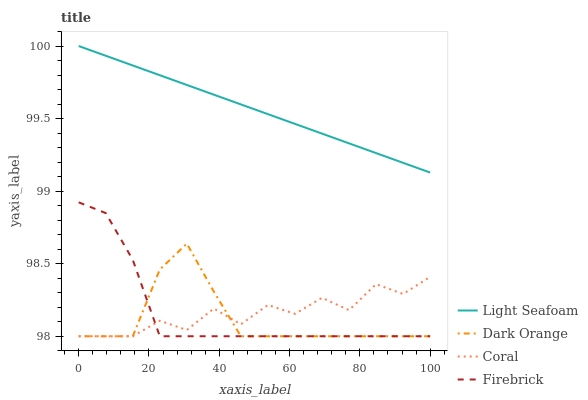Does Dark Orange have the minimum area under the curve?
Answer yes or no. Yes. Does Light Seafoam have the maximum area under the curve?
Answer yes or no. Yes. Does Coral have the minimum area under the curve?
Answer yes or no. No. Does Coral have the maximum area under the curve?
Answer yes or no. No. Is Light Seafoam the smoothest?
Answer yes or no. Yes. Is Coral the roughest?
Answer yes or no. Yes. Is Coral the smoothest?
Answer yes or no. No. Is Light Seafoam the roughest?
Answer yes or no. No. Does Light Seafoam have the lowest value?
Answer yes or no. No. Does Light Seafoam have the highest value?
Answer yes or no. Yes. Does Coral have the highest value?
Answer yes or no. No. Is Firebrick less than Light Seafoam?
Answer yes or no. Yes. Is Light Seafoam greater than Coral?
Answer yes or no. Yes. Does Firebrick intersect Coral?
Answer yes or no. Yes. Is Firebrick less than Coral?
Answer yes or no. No. Is Firebrick greater than Coral?
Answer yes or no. No. Does Firebrick intersect Light Seafoam?
Answer yes or no. No. 